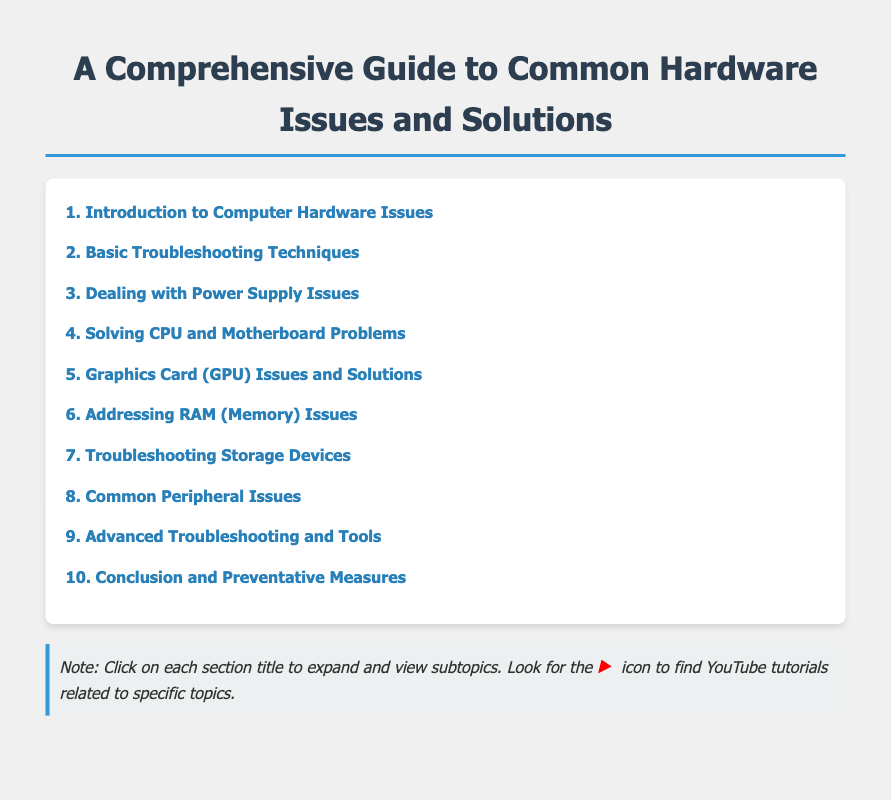What is the first topic in the table of contents? The first topic listed in the table of contents is "Introduction to Computer Hardware Issues."
Answer: Introduction to Computer Hardware Issues How many subtopics are under the section "Dealing with Power Supply Issues"? The section "Dealing with Power Supply Issues" contains three subtopics.
Answer: 3 Which YouTube channel is mentioned for troubleshooting the power supply? The channel mentioned for troubleshooting the power supply is Linus Tech Tips.
Answer: Linus Tech Tips What section deals with video card problems? The section that addresses video card problems is "Graphics Card (GPU) Issues and Solutions."
Answer: Graphics Card (GPU) Issues and Solutions How many basic troubleshooting techniques are listed? There are three basic troubleshooting techniques listed in the document.
Answer: 3 Which subtopic covers RAM diagnostics? The subtopic that covers RAM diagnostics is "Running MemTest86 for RAM Diagnostics."
Answer: Running MemTest86 for RAM Diagnostics What is the last section in the table of contents? The last section in the table of contents is "Conclusion and Preventative Measures."
Answer: Conclusion and Preventative Measures Which YouTube channel is referenced for peripheral troubleshooting tips? The channel referenced for peripheral troubleshooting tips is TechSource.
Answer: TechSource What tool is mentioned for identifying hard drive failure symptoms? The tool mentioned for identifying hard drive failure symptoms is CrystalDiskInfo.
Answer: CrystalDiskInfo 